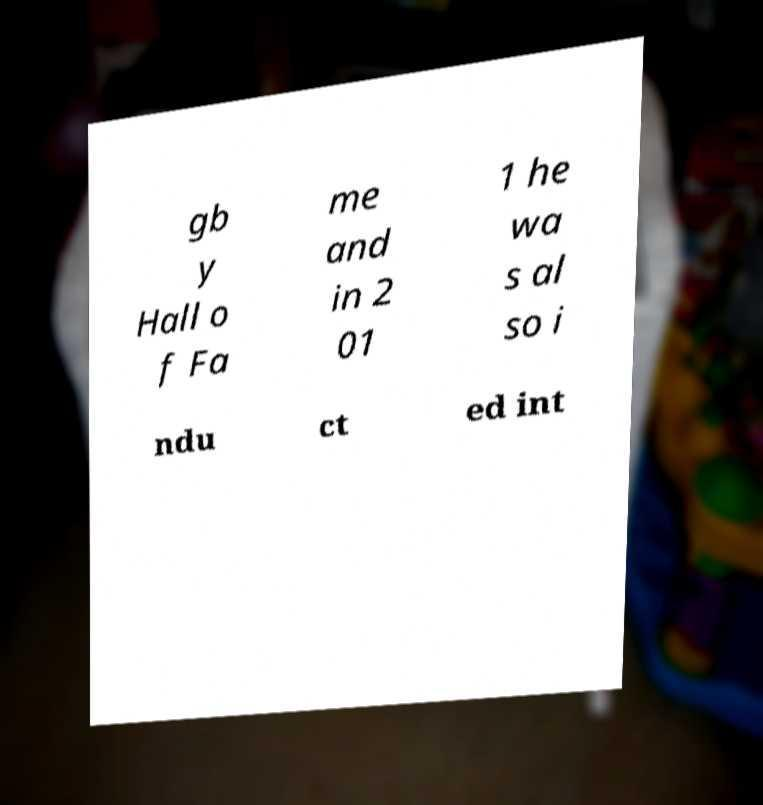I need the written content from this picture converted into text. Can you do that? gb y Hall o f Fa me and in 2 01 1 he wa s al so i ndu ct ed int 